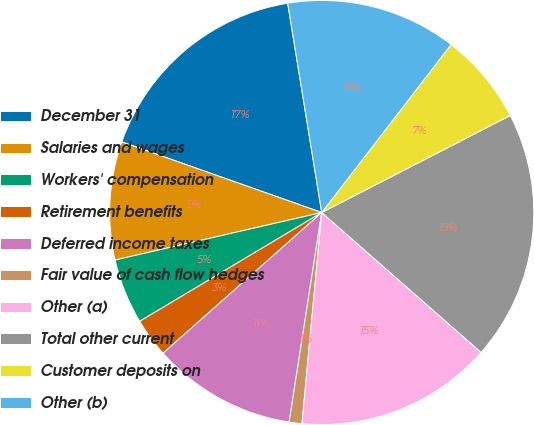<chart> <loc_0><loc_0><loc_500><loc_500><pie_chart><fcel>December 31<fcel>Salaries and wages<fcel>Workers' compensation<fcel>Retirement benefits<fcel>Deferred income taxes<fcel>Fair value of cash flow hedges<fcel>Other (a)<fcel>Total other current<fcel>Customer deposits on<fcel>Other (b)<nl><fcel>17.03%<fcel>9.0%<fcel>4.98%<fcel>2.97%<fcel>11.0%<fcel>0.97%<fcel>15.02%<fcel>19.03%<fcel>6.99%<fcel>13.01%<nl></chart> 